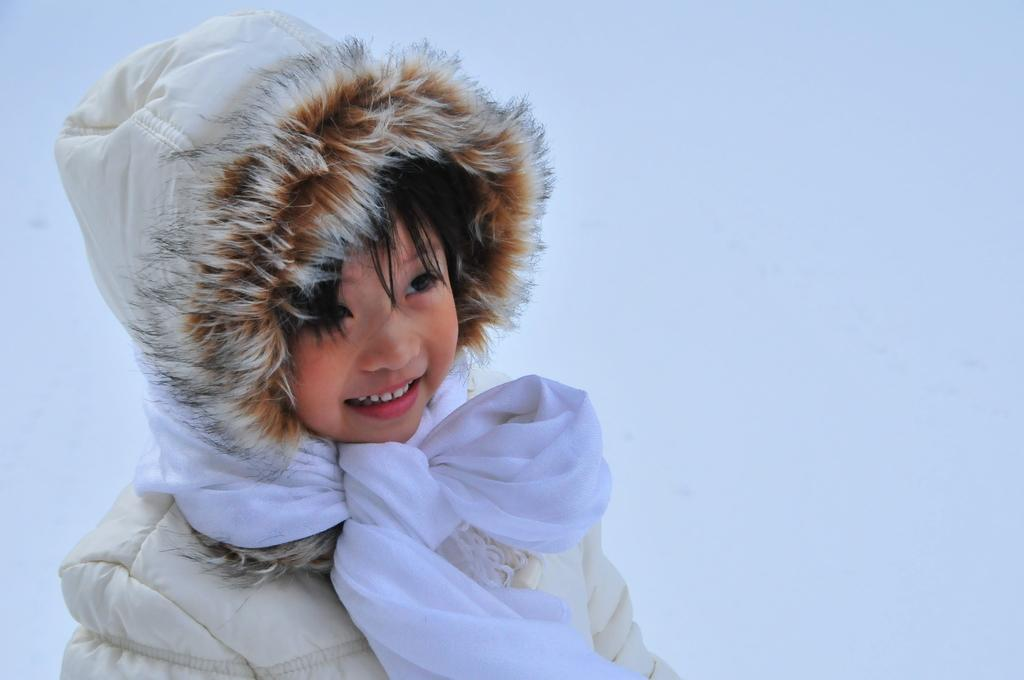What is the main subject of the image? The main subject of the image is a kid. What is the kid wearing in the image? The kid is wearing a jacket and a scarf in the image. What is the kid's facial expression in the image? The kid is smiling in the image. What can be seen in the background of the image? Ice is visible in the background of the image. What type of environment might the image have been taken in? The image may have been taken in an icy or snowy environment, possibly on ice mountains. What type of crow can be seen interacting with the kid in the image? There is no crow present in the image; it features a kid in an icy environment. What type of society is depicted in the image? The image does not depict any society; it is a close-up of a kid in an icy environment. 